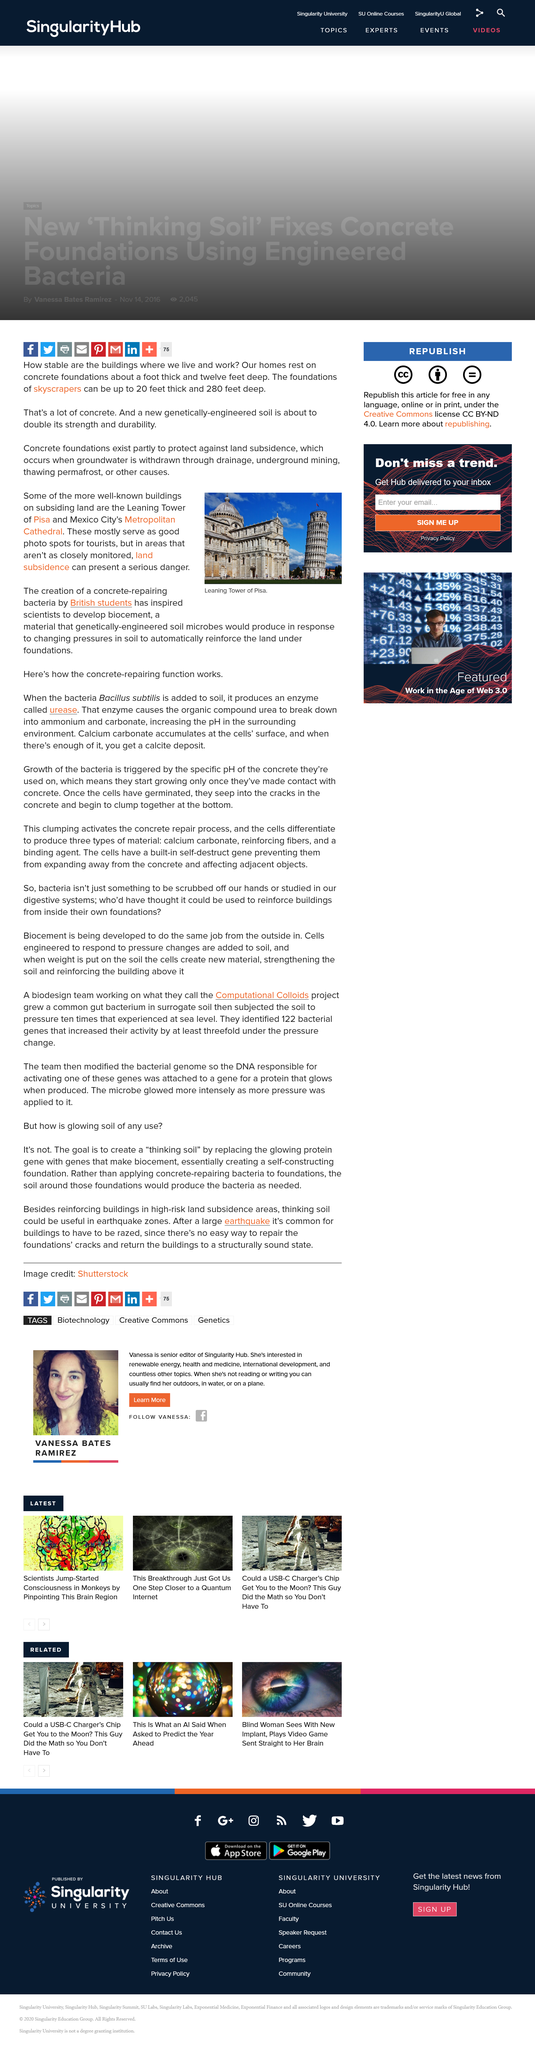Indicate a few pertinent items in this graphic. The Leaning Tower of Pisa and Mexico's Metropolitan Cathedral are both famous buildings that are at risk due to land subsidence, a hazard posed by the gradual sinking of the ground beneath them, threatening their stability and safety. Concrete foundations are essential in protecting against land subsidence. Our biocement technology has the potential to significantly enhance the strength and durability of building foundations by harnessing the natural abilities of soil microbes. By providing the necessary nutrients and conditions, biocements can encourage the growth of microorganisms that can strengthen the surrounding soil, leading to a doubling of foundation strength and improved resistance to environmental stressors. This innovative approach to construction offers a more sustainable and cost-effective solution for architects and builders looking to create foundations that are both strong and resilient. 